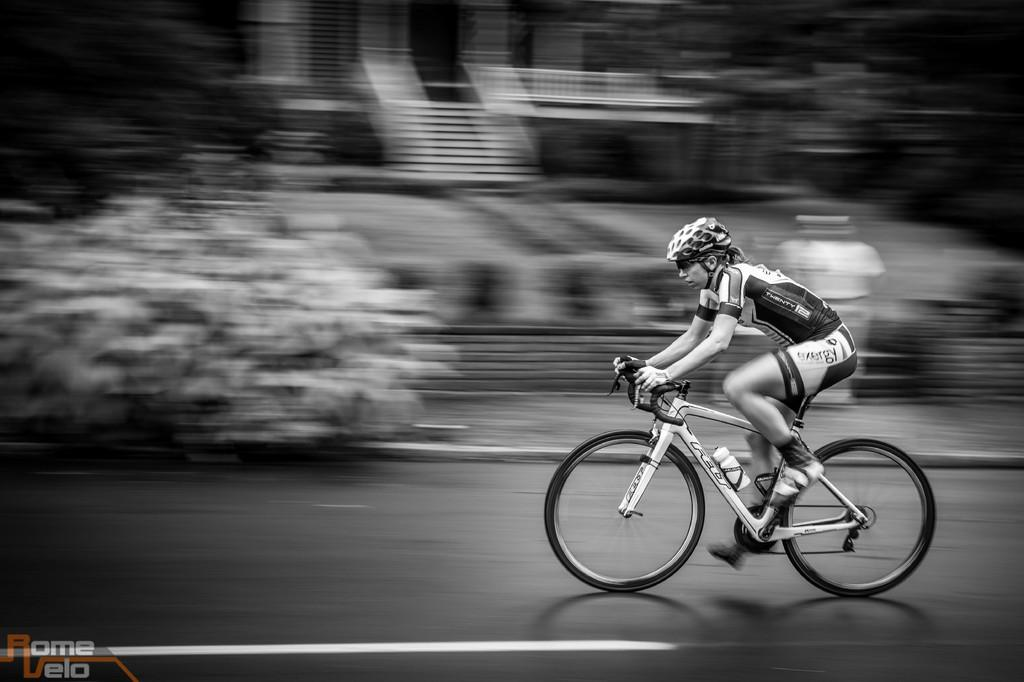Who or what is the main subject in the image? There is a person in the image. What is the person doing in the image? The person is riding a vehicle. Where is the vehicle located? The vehicle is on the road. What can be seen near the road in the image? There are plants near the road. What type of scissors can be seen cutting the banana in the image? There is no scissors or banana present in the image. How is the person treating their wound while riding the vehicle in the image? There is no wound or any indication of the person treating a wound in the image. 